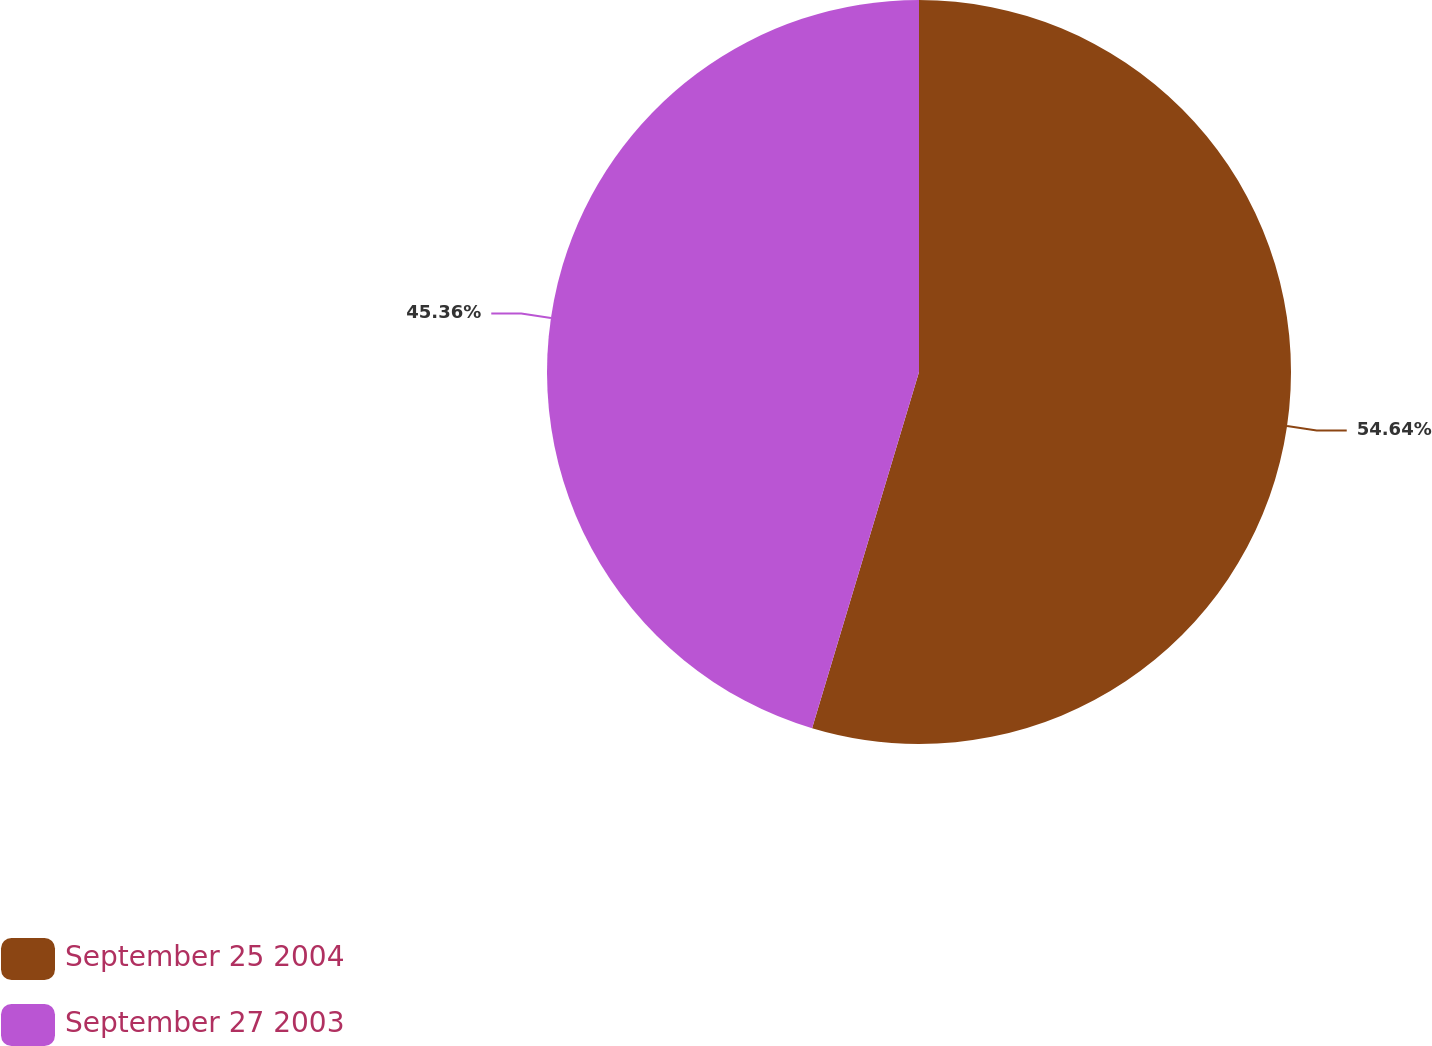Convert chart. <chart><loc_0><loc_0><loc_500><loc_500><pie_chart><fcel>September 25 2004<fcel>September 27 2003<nl><fcel>54.64%<fcel>45.36%<nl></chart> 